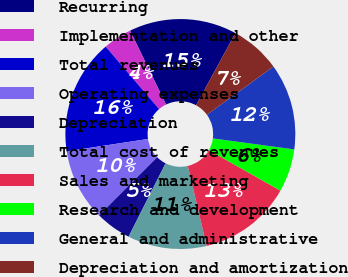Convert chart to OTSL. <chart><loc_0><loc_0><loc_500><loc_500><pie_chart><fcel>Recurring<fcel>Implementation and other<fcel>Total revenues<fcel>Operating expenses<fcel>Depreciation<fcel>Total cost of revenues<fcel>Sales and marketing<fcel>Research and development<fcel>General and administrative<fcel>Depreciation and amortization<nl><fcel>15.15%<fcel>4.05%<fcel>16.16%<fcel>10.1%<fcel>5.06%<fcel>11.11%<fcel>13.13%<fcel>6.06%<fcel>12.12%<fcel>7.07%<nl></chart> 